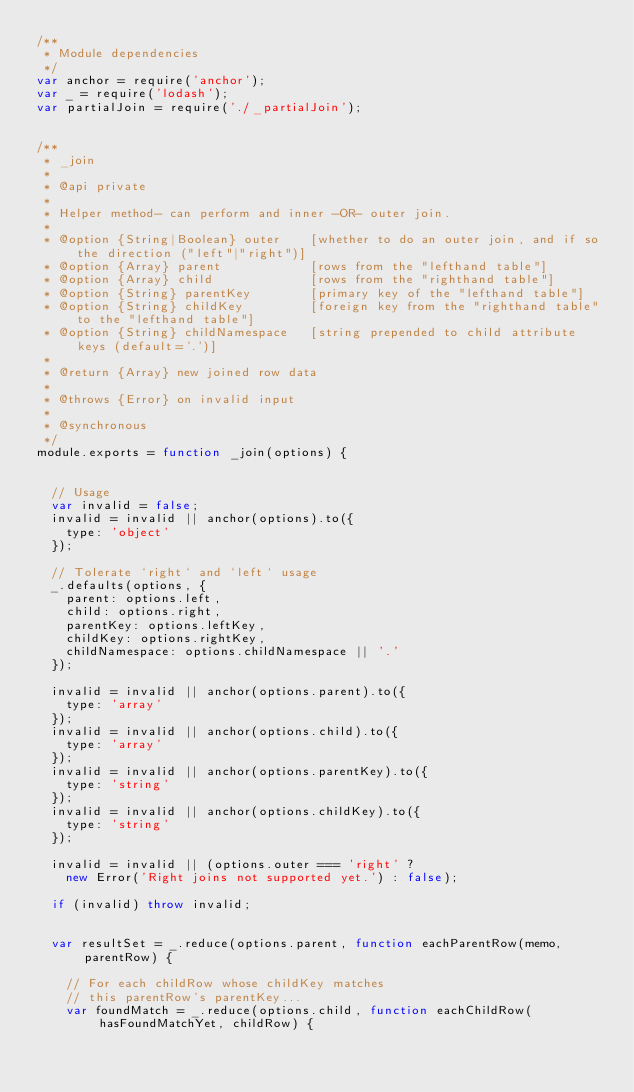Convert code to text. <code><loc_0><loc_0><loc_500><loc_500><_JavaScript_>/**
 * Module dependencies
 */
var anchor = require('anchor');
var _ = require('lodash');
var partialJoin = require('./_partialJoin');


/**
 * _join
 *
 * @api private
 *
 * Helper method- can perform and inner -OR- outer join.
 *
 * @option {String|Boolean} outer    [whether to do an outer join, and if so the direction ("left"|"right")]
 * @option {Array} parent            [rows from the "lefthand table"]
 * @option {Array} child             [rows from the "righthand table"]
 * @option {String} parentKey        [primary key of the "lefthand table"]
 * @option {String} childKey         [foreign key from the "righthand table" to the "lefthand table"]
 * @option {String} childNamespace   [string prepended to child attribute keys (default='.')]
 *
 * @return {Array} new joined row data
 *
 * @throws {Error} on invalid input
 *
 * @synchronous
 */
module.exports = function _join(options) {


  // Usage
  var invalid = false;
  invalid = invalid || anchor(options).to({
    type: 'object'
  });

  // Tolerate `right` and `left` usage
  _.defaults(options, {
    parent: options.left,
    child: options.right,
    parentKey: options.leftKey,
    childKey: options.rightKey,
    childNamespace: options.childNamespace || '.'
  });

  invalid = invalid || anchor(options.parent).to({
    type: 'array'
  });
  invalid = invalid || anchor(options.child).to({
    type: 'array'
  });
  invalid = invalid || anchor(options.parentKey).to({
    type: 'string'
  });
  invalid = invalid || anchor(options.childKey).to({
    type: 'string'
  });

  invalid = invalid || (options.outer === 'right' ?
    new Error('Right joins not supported yet.') : false);

  if (invalid) throw invalid;


  var resultSet = _.reduce(options.parent, function eachParentRow(memo, parentRow) {

    // For each childRow whose childKey matches
    // this parentRow's parentKey...
    var foundMatch = _.reduce(options.child, function eachChildRow(hasFoundMatchYet, childRow) {
</code> 